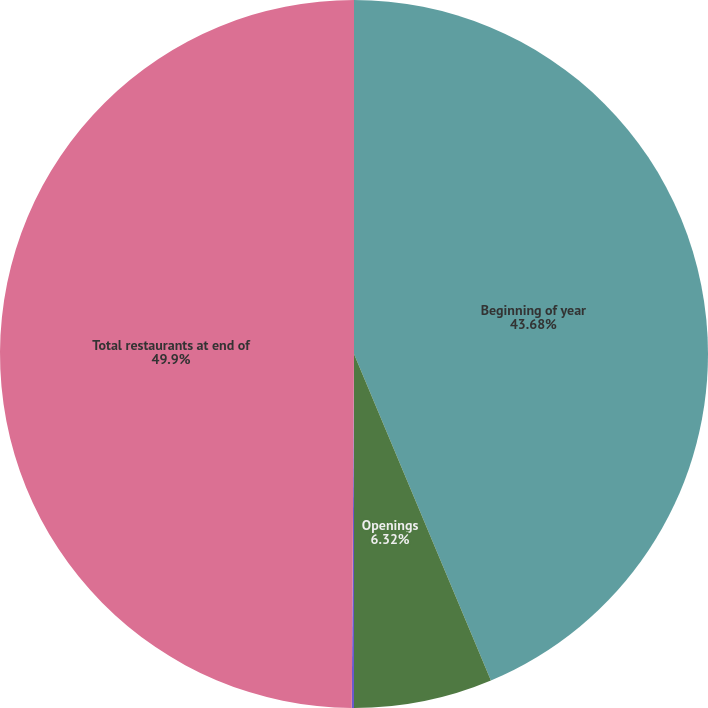Convert chart. <chart><loc_0><loc_0><loc_500><loc_500><pie_chart><fcel>Beginning of year<fcel>Openings<fcel>Closures and Relocations<fcel>Total restaurants at end of<nl><fcel>43.68%<fcel>6.32%<fcel>0.1%<fcel>49.9%<nl></chart> 